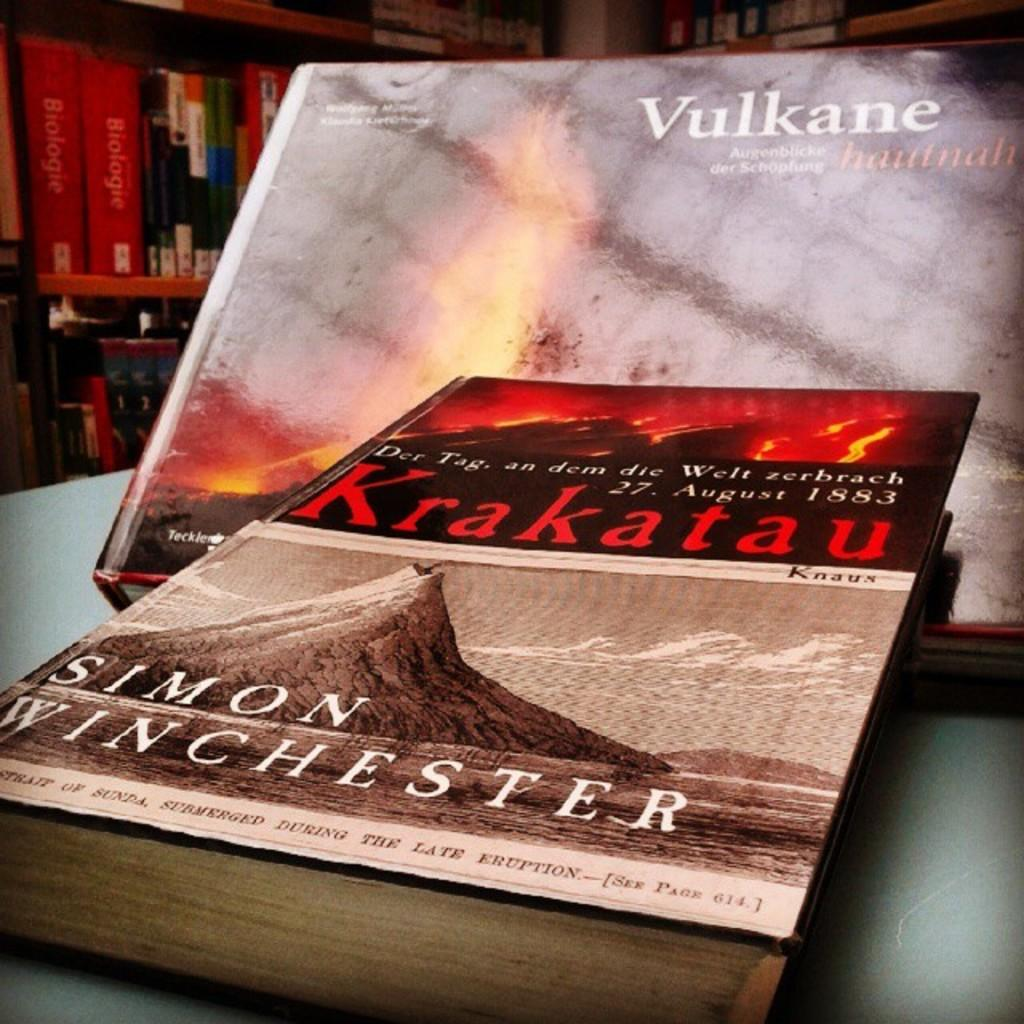What objects are in the front of the image? There are two books in the front of the image. What can be seen on the cover of the books? There is text on the cover of the books. What is located in the background of the image? There is a rack in the background of the image. What is on the rack in the background? There are books on the rack in the background. What type of soap is on the rack in the image? There is no soap present in the image; it features books on a rack. What reward is given to the person who reads the most books in the image? There is no indication of a reward or competition in the image; it simply shows books on a rack. 